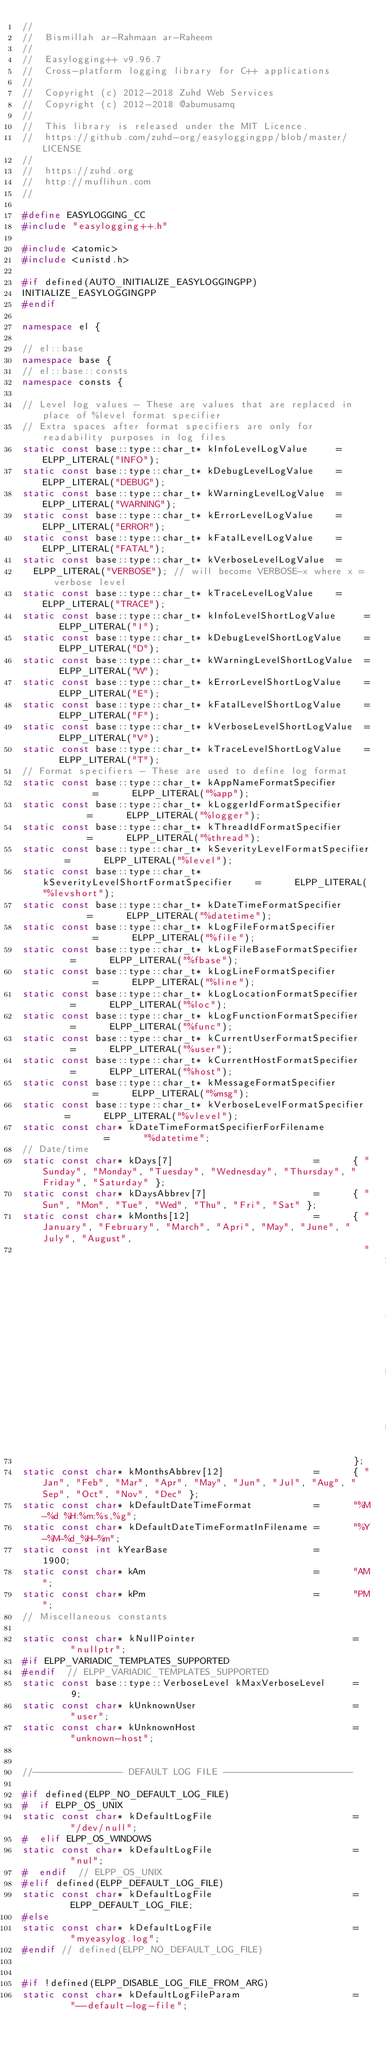<code> <loc_0><loc_0><loc_500><loc_500><_C++_>//
//  Bismillah ar-Rahmaan ar-Raheem
//
//  Easylogging++ v9.96.7
//  Cross-platform logging library for C++ applications
//
//  Copyright (c) 2012-2018 Zuhd Web Services
//  Copyright (c) 2012-2018 @abumusamq
//
//  This library is released under the MIT Licence.
//  https://github.com/zuhd-org/easyloggingpp/blob/master/LICENSE
//
//  https://zuhd.org
//  http://muflihun.com
//

#define EASYLOGGING_CC
#include "easylogging++.h"

#include <atomic>
#include <unistd.h>

#if defined(AUTO_INITIALIZE_EASYLOGGINGPP)
INITIALIZE_EASYLOGGINGPP
#endif

namespace el {

// el::base
namespace base {
// el::base::consts
namespace consts {

// Level log values - These are values that are replaced in place of %level format specifier
// Extra spaces after format specifiers are only for readability purposes in log files
static const base::type::char_t* kInfoLevelLogValue     =   ELPP_LITERAL("INFO");
static const base::type::char_t* kDebugLevelLogValue    =   ELPP_LITERAL("DEBUG");
static const base::type::char_t* kWarningLevelLogValue  =   ELPP_LITERAL("WARNING");
static const base::type::char_t* kErrorLevelLogValue    =   ELPP_LITERAL("ERROR");
static const base::type::char_t* kFatalLevelLogValue    =   ELPP_LITERAL("FATAL");
static const base::type::char_t* kVerboseLevelLogValue  =
  ELPP_LITERAL("VERBOSE"); // will become VERBOSE-x where x = verbose level
static const base::type::char_t* kTraceLevelLogValue    =   ELPP_LITERAL("TRACE");
static const base::type::char_t* kInfoLevelShortLogValue     =   ELPP_LITERAL("I");
static const base::type::char_t* kDebugLevelShortLogValue    =   ELPP_LITERAL("D");
static const base::type::char_t* kWarningLevelShortLogValue  =   ELPP_LITERAL("W");
static const base::type::char_t* kErrorLevelShortLogValue    =   ELPP_LITERAL("E");
static const base::type::char_t* kFatalLevelShortLogValue    =   ELPP_LITERAL("F");
static const base::type::char_t* kVerboseLevelShortLogValue  =   ELPP_LITERAL("V");
static const base::type::char_t* kTraceLevelShortLogValue    =   ELPP_LITERAL("T");
// Format specifiers - These are used to define log format
static const base::type::char_t* kAppNameFormatSpecifier          =      ELPP_LITERAL("%app");
static const base::type::char_t* kLoggerIdFormatSpecifier         =      ELPP_LITERAL("%logger");
static const base::type::char_t* kThreadIdFormatSpecifier         =      ELPP_LITERAL("%thread");
static const base::type::char_t* kSeverityLevelFormatSpecifier    =      ELPP_LITERAL("%level");
static const base::type::char_t* kSeverityLevelShortFormatSpecifier    =      ELPP_LITERAL("%levshort");
static const base::type::char_t* kDateTimeFormatSpecifier         =      ELPP_LITERAL("%datetime");
static const base::type::char_t* kLogFileFormatSpecifier          =      ELPP_LITERAL("%file");
static const base::type::char_t* kLogFileBaseFormatSpecifier      =      ELPP_LITERAL("%fbase");
static const base::type::char_t* kLogLineFormatSpecifier          =      ELPP_LITERAL("%line");
static const base::type::char_t* kLogLocationFormatSpecifier      =      ELPP_LITERAL("%loc");
static const base::type::char_t* kLogFunctionFormatSpecifier      =      ELPP_LITERAL("%func");
static const base::type::char_t* kCurrentUserFormatSpecifier      =      ELPP_LITERAL("%user");
static const base::type::char_t* kCurrentHostFormatSpecifier      =      ELPP_LITERAL("%host");
static const base::type::char_t* kMessageFormatSpecifier          =      ELPP_LITERAL("%msg");
static const base::type::char_t* kVerboseLevelFormatSpecifier     =      ELPP_LITERAL("%vlevel");
static const char* kDateTimeFormatSpecifierForFilename            =      "%datetime";
// Date/time
static const char* kDays[7]                         =      { "Sunday", "Monday", "Tuesday", "Wednesday", "Thursday", "Friday", "Saturday" };
static const char* kDaysAbbrev[7]                   =      { "Sun", "Mon", "Tue", "Wed", "Thu", "Fri", "Sat" };
static const char* kMonths[12]                      =      { "January", "February", "March", "Apri", "May", "June", "July", "August",
                                                             "September", "October", "November", "December"
                                                           };
static const char* kMonthsAbbrev[12]                =      { "Jan", "Feb", "Mar", "Apr", "May", "Jun", "Jul", "Aug", "Sep", "Oct", "Nov", "Dec" };
static const char* kDefaultDateTimeFormat           =      "%M-%d %H:%m:%s,%g";
static const char* kDefaultDateTimeFormatInFilename =      "%Y-%M-%d_%H-%m";
static const int kYearBase                          =      1900;
static const char* kAm                              =      "AM";
static const char* kPm                              =      "PM";
// Miscellaneous constants

static const char* kNullPointer                            =      "nullptr";
#if ELPP_VARIADIC_TEMPLATES_SUPPORTED
#endif  // ELPP_VARIADIC_TEMPLATES_SUPPORTED
static const base::type::VerboseLevel kMaxVerboseLevel     =      9;
static const char* kUnknownUser                            =      "user";
static const char* kUnknownHost                            =      "unknown-host";


//---------------- DEFAULT LOG FILE -----------------------

#if defined(ELPP_NO_DEFAULT_LOG_FILE)
#  if ELPP_OS_UNIX
static const char* kDefaultLogFile                         =      "/dev/null";
#  elif ELPP_OS_WINDOWS
static const char* kDefaultLogFile                         =      "nul";
#  endif  // ELPP_OS_UNIX
#elif defined(ELPP_DEFAULT_LOG_FILE)
static const char* kDefaultLogFile                         =      ELPP_DEFAULT_LOG_FILE;
#else
static const char* kDefaultLogFile                         =      "myeasylog.log";
#endif // defined(ELPP_NO_DEFAULT_LOG_FILE)


#if !defined(ELPP_DISABLE_LOG_FILE_FROM_ARG)
static const char* kDefaultLogFileParam                    =      "--default-log-file";</code> 